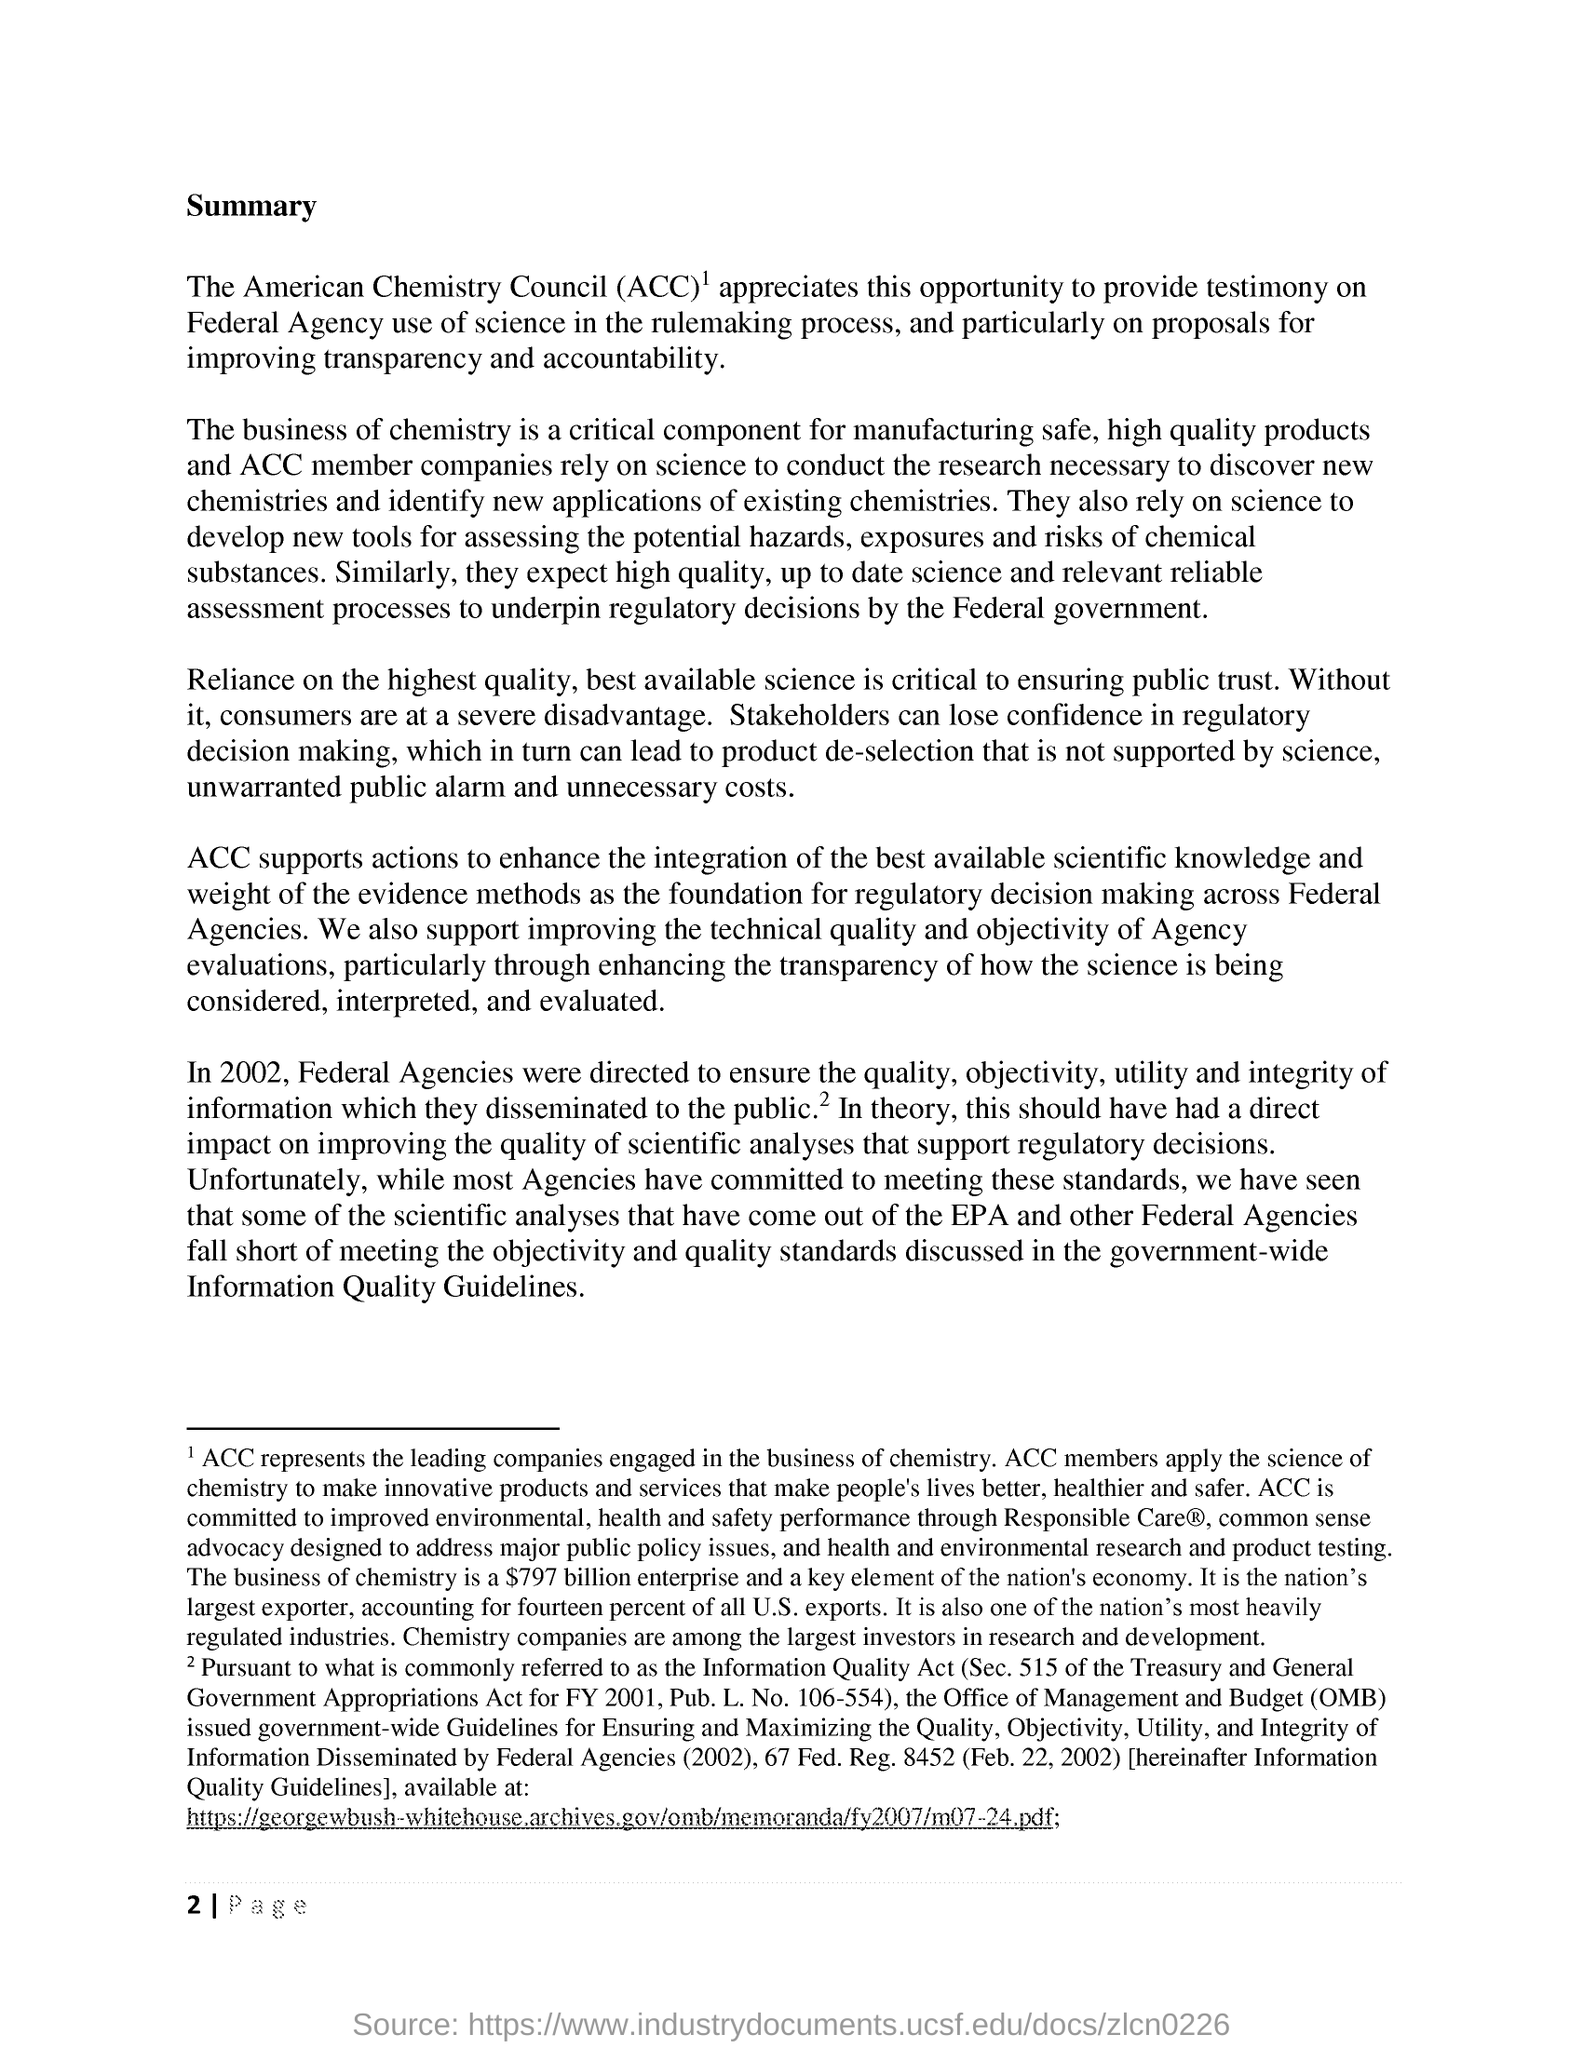Give some essential details in this illustration. The first title in the document is "Summary. The full form of ACC is the American Chemistry Council, an organization that represents the interests of the chemical industry in the United States. 